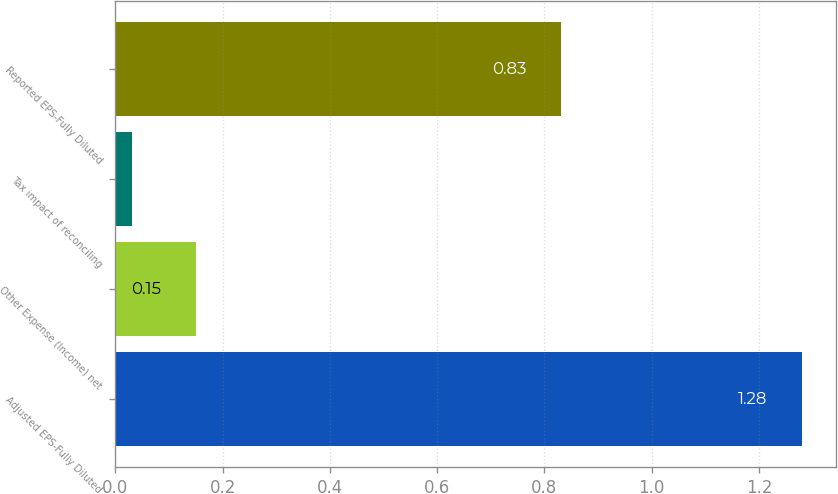<chart> <loc_0><loc_0><loc_500><loc_500><bar_chart><fcel>Adjusted EPS-Fully Diluted<fcel>Other Expense (Income) net<fcel>Tax impact of reconciling<fcel>Reported EPS-Fully Diluted<nl><fcel>1.28<fcel>0.15<fcel>0.03<fcel>0.83<nl></chart> 